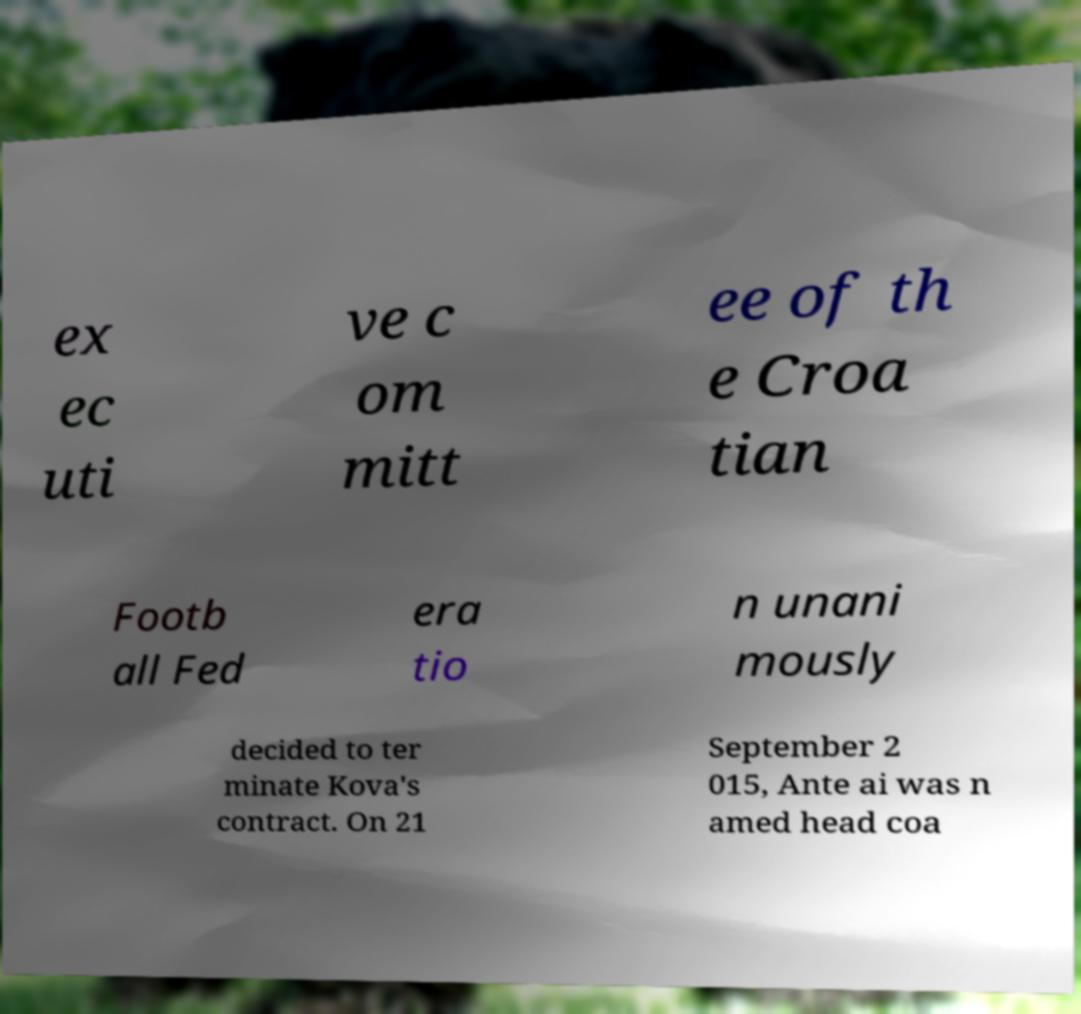Can you read and provide the text displayed in the image?This photo seems to have some interesting text. Can you extract and type it out for me? ex ec uti ve c om mitt ee of th e Croa tian Footb all Fed era tio n unani mously decided to ter minate Kova's contract. On 21 September 2 015, Ante ai was n amed head coa 